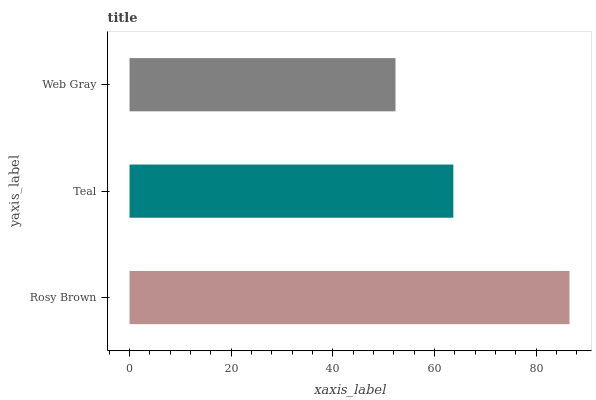Is Web Gray the minimum?
Answer yes or no. Yes. Is Rosy Brown the maximum?
Answer yes or no. Yes. Is Teal the minimum?
Answer yes or no. No. Is Teal the maximum?
Answer yes or no. No. Is Rosy Brown greater than Teal?
Answer yes or no. Yes. Is Teal less than Rosy Brown?
Answer yes or no. Yes. Is Teal greater than Rosy Brown?
Answer yes or no. No. Is Rosy Brown less than Teal?
Answer yes or no. No. Is Teal the high median?
Answer yes or no. Yes. Is Teal the low median?
Answer yes or no. Yes. Is Rosy Brown the high median?
Answer yes or no. No. Is Rosy Brown the low median?
Answer yes or no. No. 